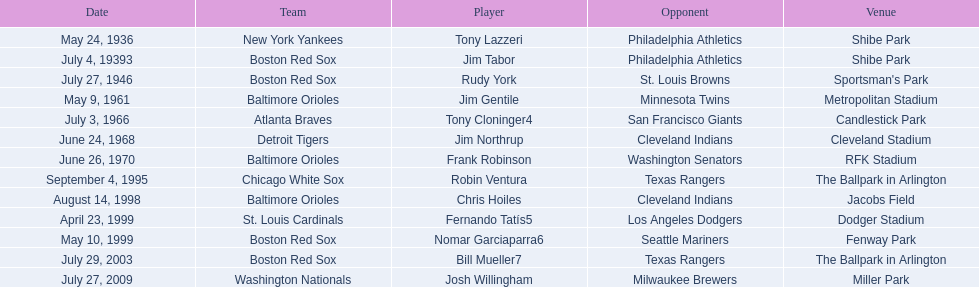Who was the opponent for the boston red sox on july 27, 1946? St. Louis Browns. 